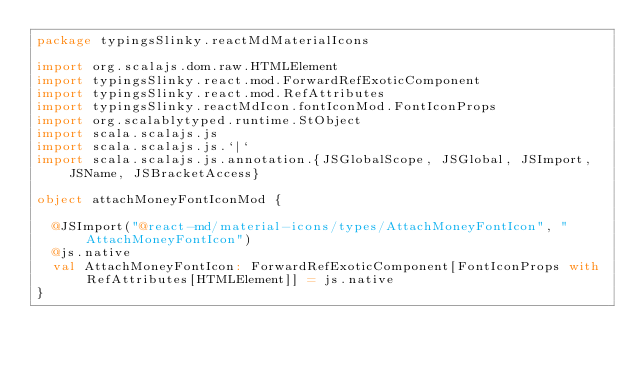<code> <loc_0><loc_0><loc_500><loc_500><_Scala_>package typingsSlinky.reactMdMaterialIcons

import org.scalajs.dom.raw.HTMLElement
import typingsSlinky.react.mod.ForwardRefExoticComponent
import typingsSlinky.react.mod.RefAttributes
import typingsSlinky.reactMdIcon.fontIconMod.FontIconProps
import org.scalablytyped.runtime.StObject
import scala.scalajs.js
import scala.scalajs.js.`|`
import scala.scalajs.js.annotation.{JSGlobalScope, JSGlobal, JSImport, JSName, JSBracketAccess}

object attachMoneyFontIconMod {
  
  @JSImport("@react-md/material-icons/types/AttachMoneyFontIcon", "AttachMoneyFontIcon")
  @js.native
  val AttachMoneyFontIcon: ForwardRefExoticComponent[FontIconProps with RefAttributes[HTMLElement]] = js.native
}
</code> 